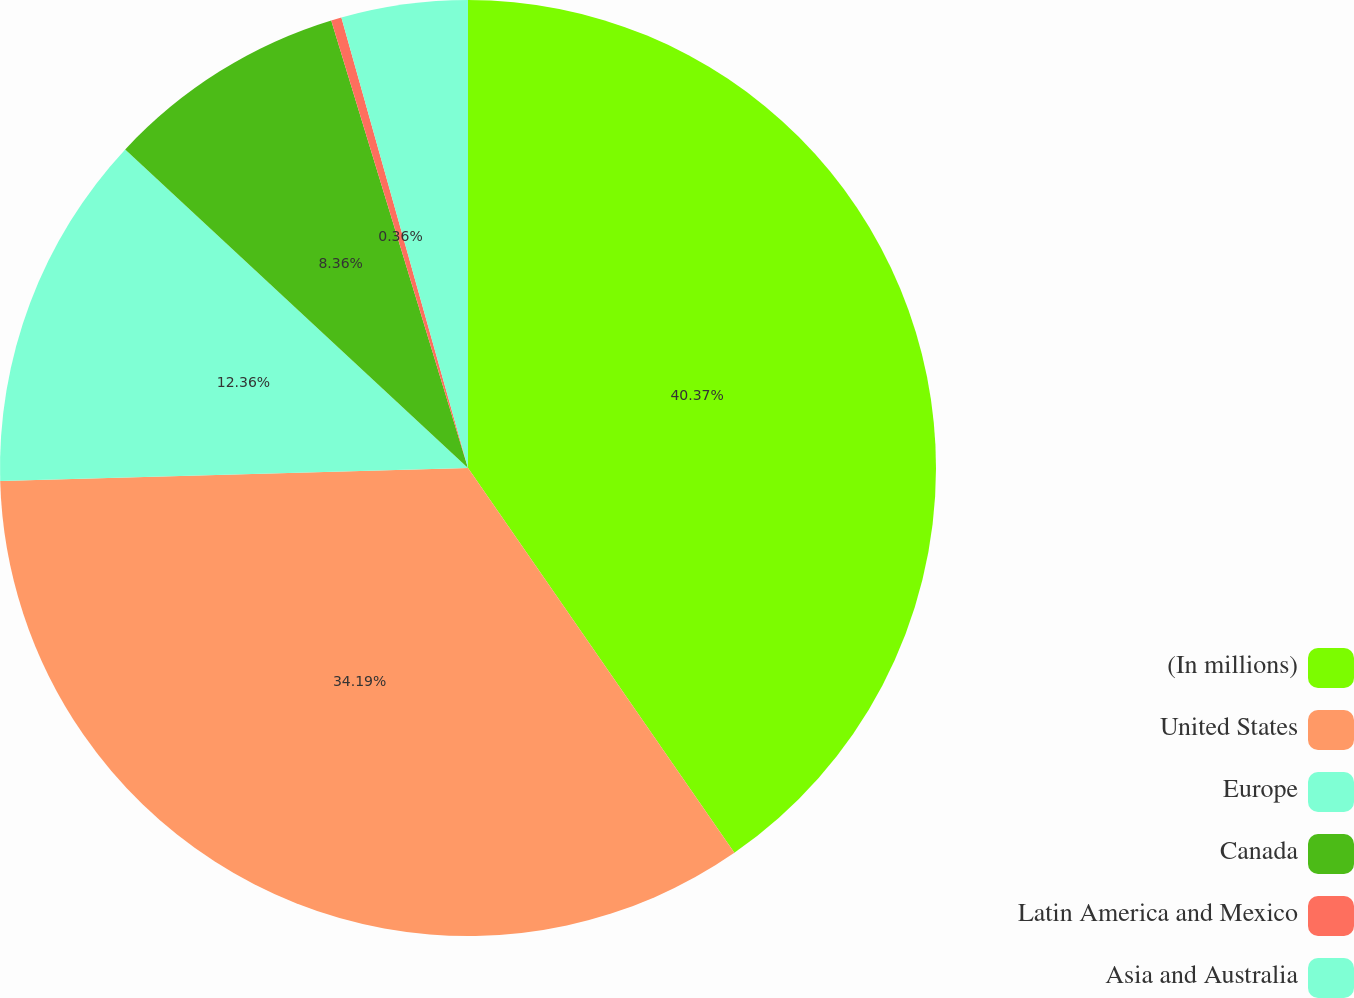Convert chart. <chart><loc_0><loc_0><loc_500><loc_500><pie_chart><fcel>(In millions)<fcel>United States<fcel>Europe<fcel>Canada<fcel>Latin America and Mexico<fcel>Asia and Australia<nl><fcel>40.36%<fcel>34.19%<fcel>12.36%<fcel>8.36%<fcel>0.36%<fcel>4.36%<nl></chart> 